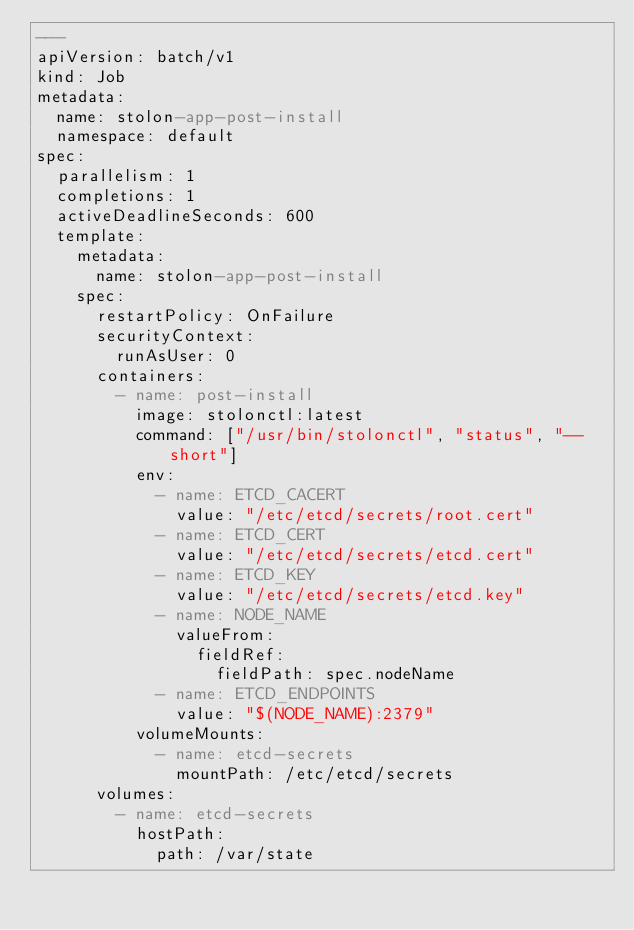Convert code to text. <code><loc_0><loc_0><loc_500><loc_500><_YAML_>---
apiVersion: batch/v1
kind: Job
metadata:
  name: stolon-app-post-install
  namespace: default
spec:
  parallelism: 1
  completions: 1
  activeDeadlineSeconds: 600
  template:
    metadata:
      name: stolon-app-post-install
    spec:
      restartPolicy: OnFailure
      securityContext:
        runAsUser: 0
      containers:
        - name: post-install
          image: stolonctl:latest
          command: ["/usr/bin/stolonctl", "status", "--short"]
          env:
            - name: ETCD_CACERT
              value: "/etc/etcd/secrets/root.cert"
            - name: ETCD_CERT
              value: "/etc/etcd/secrets/etcd.cert"
            - name: ETCD_KEY
              value: "/etc/etcd/secrets/etcd.key"
            - name: NODE_NAME
              valueFrom:
                fieldRef:
                  fieldPath: spec.nodeName
            - name: ETCD_ENDPOINTS
              value: "$(NODE_NAME):2379"
          volumeMounts:
            - name: etcd-secrets
              mountPath: /etc/etcd/secrets
      volumes:
        - name: etcd-secrets
          hostPath:
            path: /var/state
</code> 